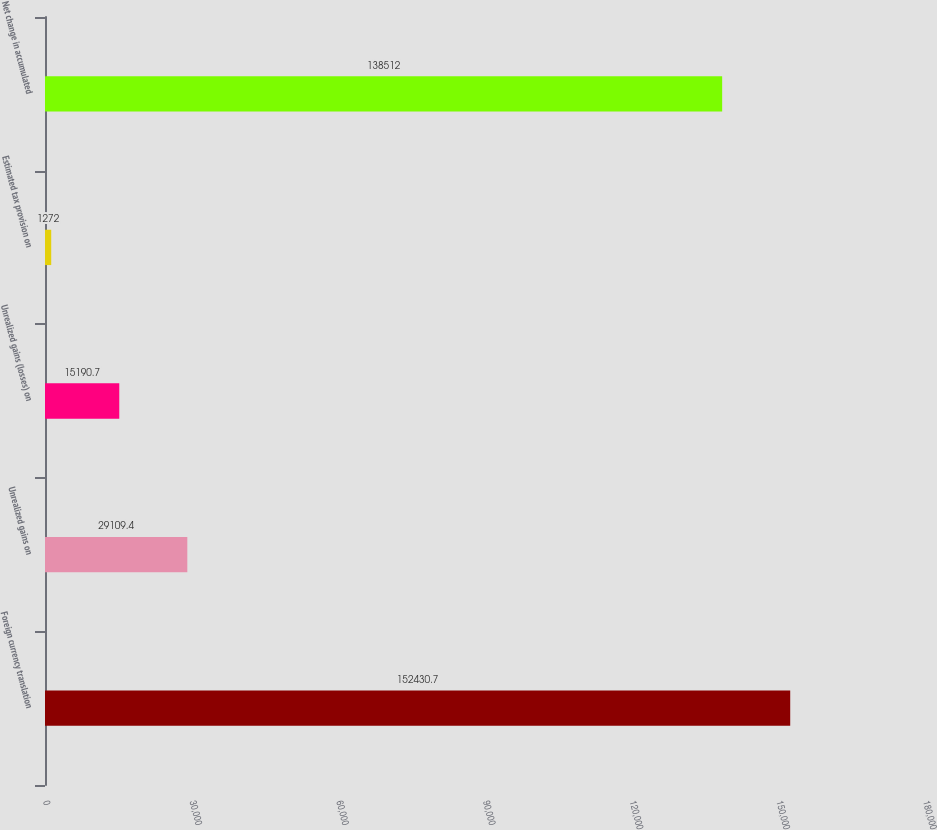Convert chart. <chart><loc_0><loc_0><loc_500><loc_500><bar_chart><fcel>Foreign currency translation<fcel>Unrealized gains on<fcel>Unrealized gains (losses) on<fcel>Estimated tax provision on<fcel>Net change in accumulated<nl><fcel>152431<fcel>29109.4<fcel>15190.7<fcel>1272<fcel>138512<nl></chart> 